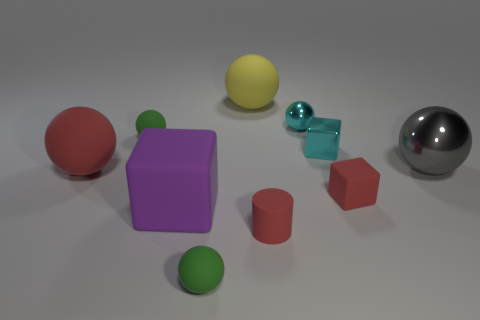Subtract all cyan blocks. How many blocks are left? 2 Subtract all red spheres. How many spheres are left? 5 Subtract all brown cylinders. How many green balls are left? 2 Subtract 0 gray cylinders. How many objects are left? 10 Subtract all spheres. How many objects are left? 4 Subtract 3 cubes. How many cubes are left? 0 Subtract all purple spheres. Subtract all gray blocks. How many spheres are left? 6 Subtract all metal spheres. Subtract all metallic objects. How many objects are left? 5 Add 9 cyan shiny cubes. How many cyan shiny cubes are left? 10 Add 8 big gray shiny objects. How many big gray shiny objects exist? 9 